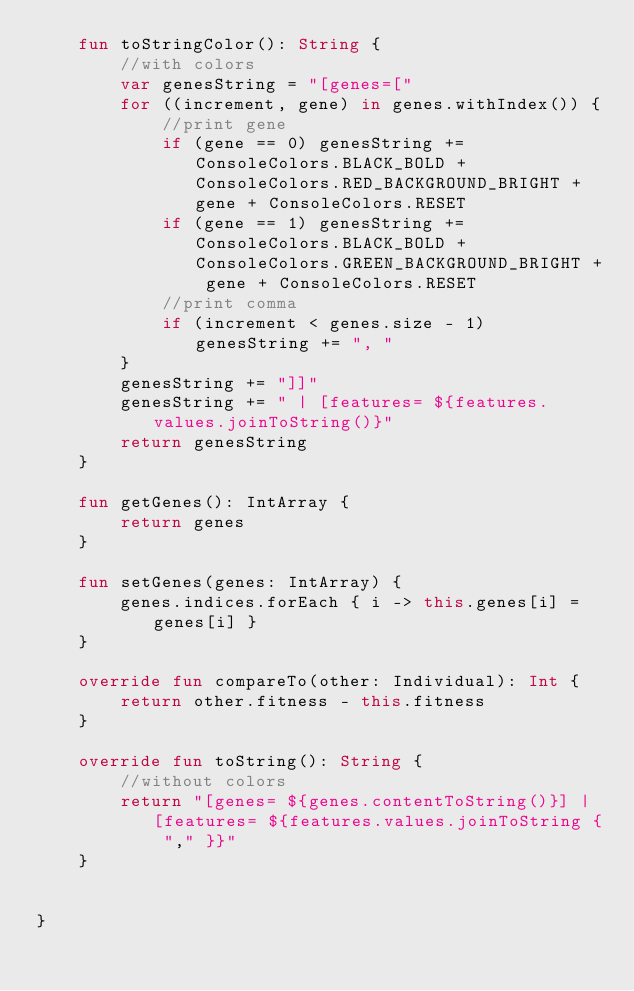<code> <loc_0><loc_0><loc_500><loc_500><_Kotlin_>    fun toStringColor(): String {
        //with colors
        var genesString = "[genes=["
        for ((increment, gene) in genes.withIndex()) {
            //print gene
            if (gene == 0) genesString += ConsoleColors.BLACK_BOLD + ConsoleColors.RED_BACKGROUND_BRIGHT + gene + ConsoleColors.RESET
            if (gene == 1) genesString += ConsoleColors.BLACK_BOLD + ConsoleColors.GREEN_BACKGROUND_BRIGHT + gene + ConsoleColors.RESET
            //print comma
            if (increment < genes.size - 1) genesString += ", "
        }
        genesString += "]]"
        genesString += " | [features= ${features.values.joinToString()}"
        return genesString
    }

    fun getGenes(): IntArray {
        return genes
    }

    fun setGenes(genes: IntArray) {
        genes.indices.forEach { i -> this.genes[i] = genes[i] }
    }

    override fun compareTo(other: Individual): Int {
        return other.fitness - this.fitness
    }

    override fun toString(): String {
        //without colors
        return "[genes= ${genes.contentToString()}] | [features= ${features.values.joinToString { "," }}"
    }


}</code> 